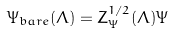Convert formula to latex. <formula><loc_0><loc_0><loc_500><loc_500>\Psi _ { b a r e } ( \Lambda ) = Z ^ { 1 / 2 } _ { \Psi } ( \Lambda ) \Psi</formula> 